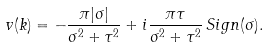Convert formula to latex. <formula><loc_0><loc_0><loc_500><loc_500>v ( k ) = - \frac { \pi | \sigma | } { \sigma ^ { 2 } + \tau ^ { 2 } } + i \frac { \pi \tau } { \sigma ^ { 2 } + \tau ^ { 2 } } \, S i g n ( \sigma ) .</formula> 